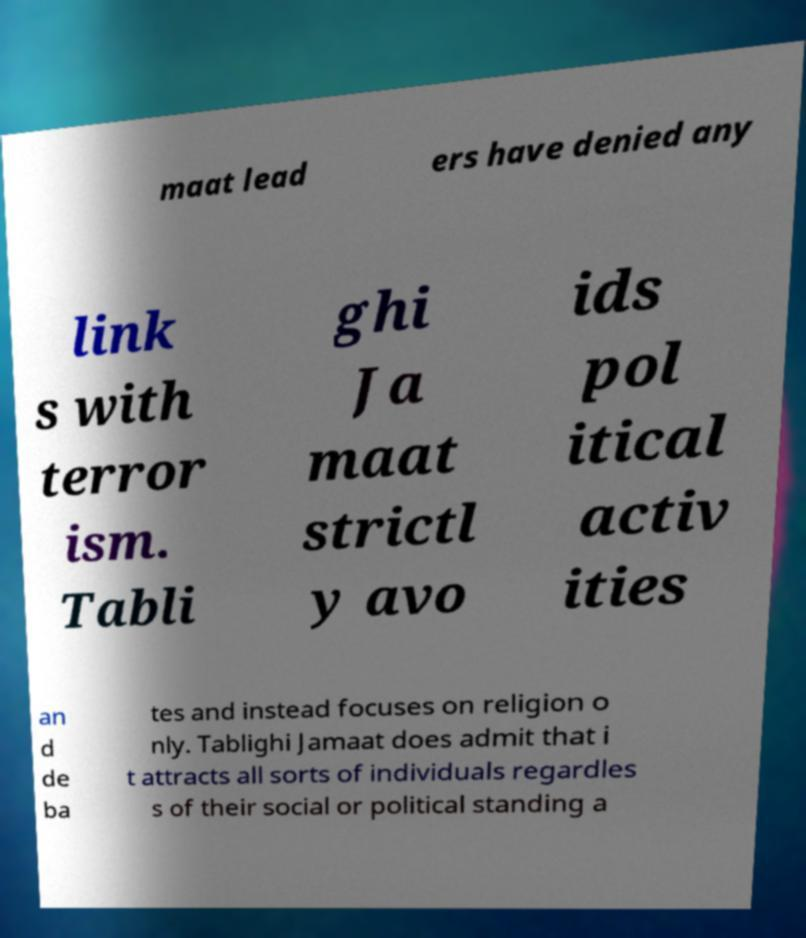Could you assist in decoding the text presented in this image and type it out clearly? maat lead ers have denied any link s with terror ism. Tabli ghi Ja maat strictl y avo ids pol itical activ ities an d de ba tes and instead focuses on religion o nly. Tablighi Jamaat does admit that i t attracts all sorts of individuals regardles s of their social or political standing a 